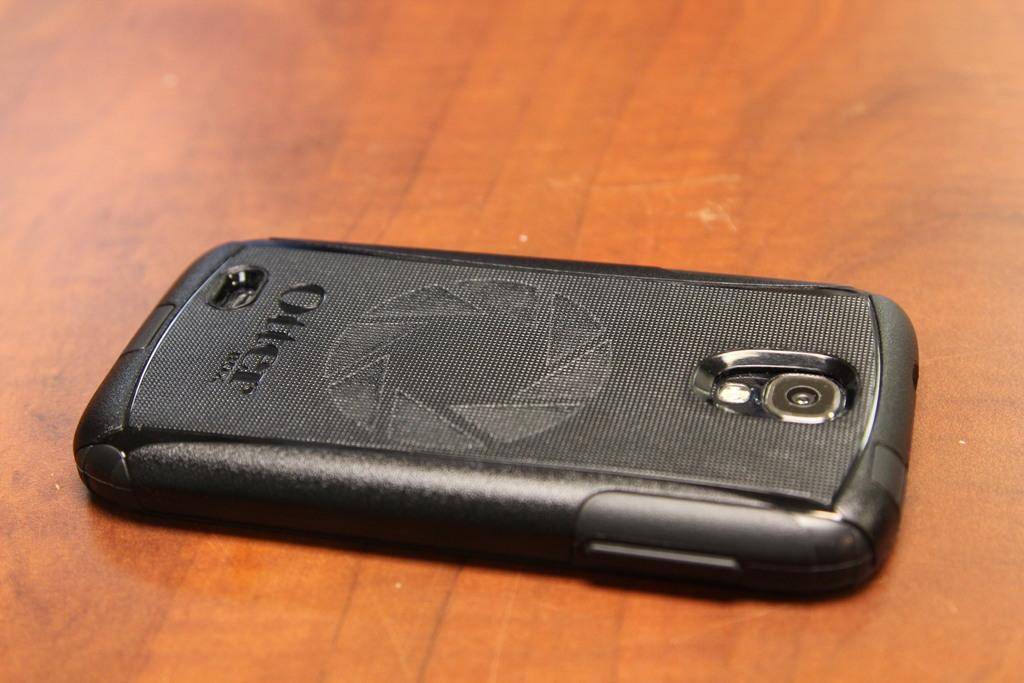Can you describe this image briefly? In this image, we can see a mobile phone on the wooden surface. 